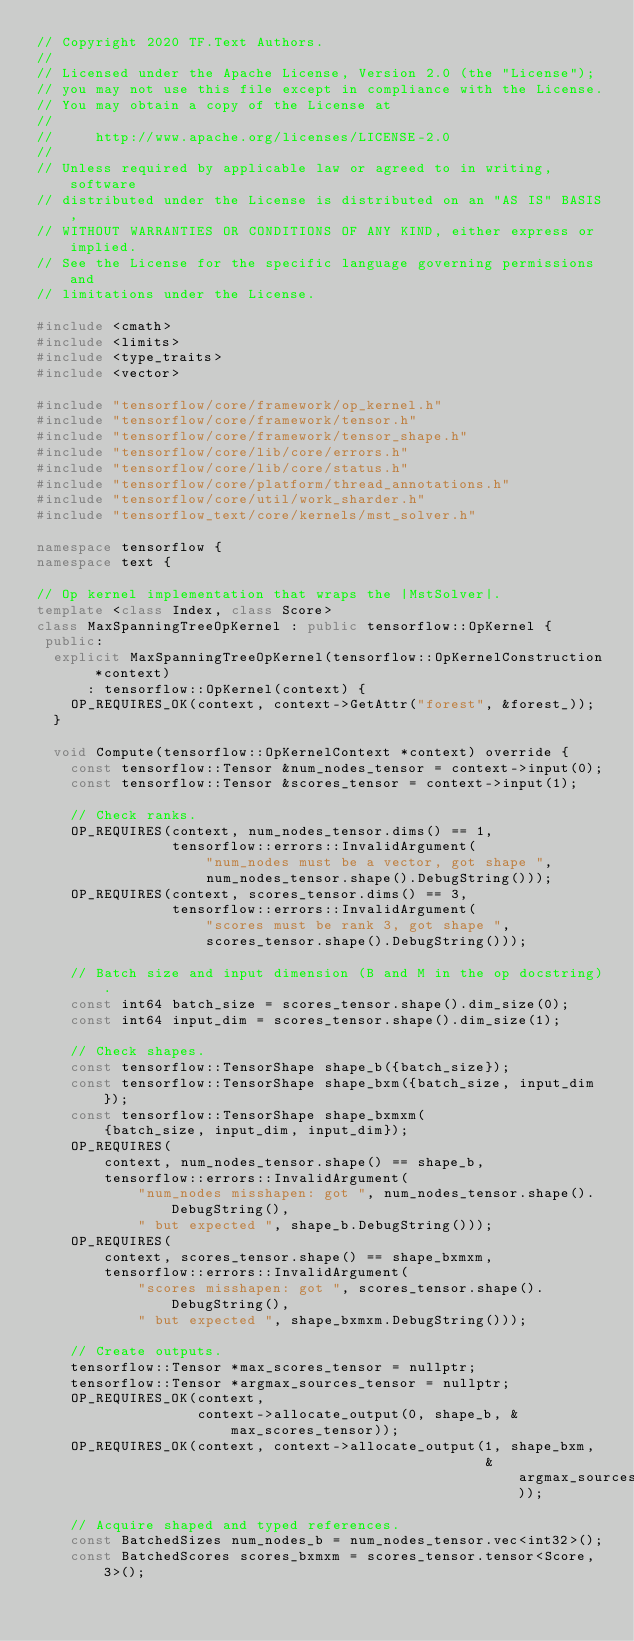<code> <loc_0><loc_0><loc_500><loc_500><_C++_>// Copyright 2020 TF.Text Authors.
//
// Licensed under the Apache License, Version 2.0 (the "License");
// you may not use this file except in compliance with the License.
// You may obtain a copy of the License at
//
//     http://www.apache.org/licenses/LICENSE-2.0
//
// Unless required by applicable law or agreed to in writing, software
// distributed under the License is distributed on an "AS IS" BASIS,
// WITHOUT WARRANTIES OR CONDITIONS OF ANY KIND, either express or implied.
// See the License for the specific language governing permissions and
// limitations under the License.

#include <cmath>
#include <limits>
#include <type_traits>
#include <vector>

#include "tensorflow/core/framework/op_kernel.h"
#include "tensorflow/core/framework/tensor.h"
#include "tensorflow/core/framework/tensor_shape.h"
#include "tensorflow/core/lib/core/errors.h"
#include "tensorflow/core/lib/core/status.h"
#include "tensorflow/core/platform/thread_annotations.h"
#include "tensorflow/core/util/work_sharder.h"
#include "tensorflow_text/core/kernels/mst_solver.h"

namespace tensorflow {
namespace text {

// Op kernel implementation that wraps the |MstSolver|.
template <class Index, class Score>
class MaxSpanningTreeOpKernel : public tensorflow::OpKernel {
 public:
  explicit MaxSpanningTreeOpKernel(tensorflow::OpKernelConstruction *context)
      : tensorflow::OpKernel(context) {
    OP_REQUIRES_OK(context, context->GetAttr("forest", &forest_));
  }

  void Compute(tensorflow::OpKernelContext *context) override {
    const tensorflow::Tensor &num_nodes_tensor = context->input(0);
    const tensorflow::Tensor &scores_tensor = context->input(1);

    // Check ranks.
    OP_REQUIRES(context, num_nodes_tensor.dims() == 1,
                tensorflow::errors::InvalidArgument(
                    "num_nodes must be a vector, got shape ",
                    num_nodes_tensor.shape().DebugString()));
    OP_REQUIRES(context, scores_tensor.dims() == 3,
                tensorflow::errors::InvalidArgument(
                    "scores must be rank 3, got shape ",
                    scores_tensor.shape().DebugString()));

    // Batch size and input dimension (B and M in the op docstring).
    const int64 batch_size = scores_tensor.shape().dim_size(0);
    const int64 input_dim = scores_tensor.shape().dim_size(1);

    // Check shapes.
    const tensorflow::TensorShape shape_b({batch_size});
    const tensorflow::TensorShape shape_bxm({batch_size, input_dim});
    const tensorflow::TensorShape shape_bxmxm(
        {batch_size, input_dim, input_dim});
    OP_REQUIRES(
        context, num_nodes_tensor.shape() == shape_b,
        tensorflow::errors::InvalidArgument(
            "num_nodes misshapen: got ", num_nodes_tensor.shape().DebugString(),
            " but expected ", shape_b.DebugString()));
    OP_REQUIRES(
        context, scores_tensor.shape() == shape_bxmxm,
        tensorflow::errors::InvalidArgument(
            "scores misshapen: got ", scores_tensor.shape().DebugString(),
            " but expected ", shape_bxmxm.DebugString()));

    // Create outputs.
    tensorflow::Tensor *max_scores_tensor = nullptr;
    tensorflow::Tensor *argmax_sources_tensor = nullptr;
    OP_REQUIRES_OK(context,
                   context->allocate_output(0, shape_b, &max_scores_tensor));
    OP_REQUIRES_OK(context, context->allocate_output(1, shape_bxm,
                                                     &argmax_sources_tensor));

    // Acquire shaped and typed references.
    const BatchedSizes num_nodes_b = num_nodes_tensor.vec<int32>();
    const BatchedScores scores_bxmxm = scores_tensor.tensor<Score, 3>();</code> 